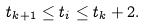<formula> <loc_0><loc_0><loc_500><loc_500>t _ { k + 1 } \leq t _ { i } \leq t _ { k } + 2 .</formula> 